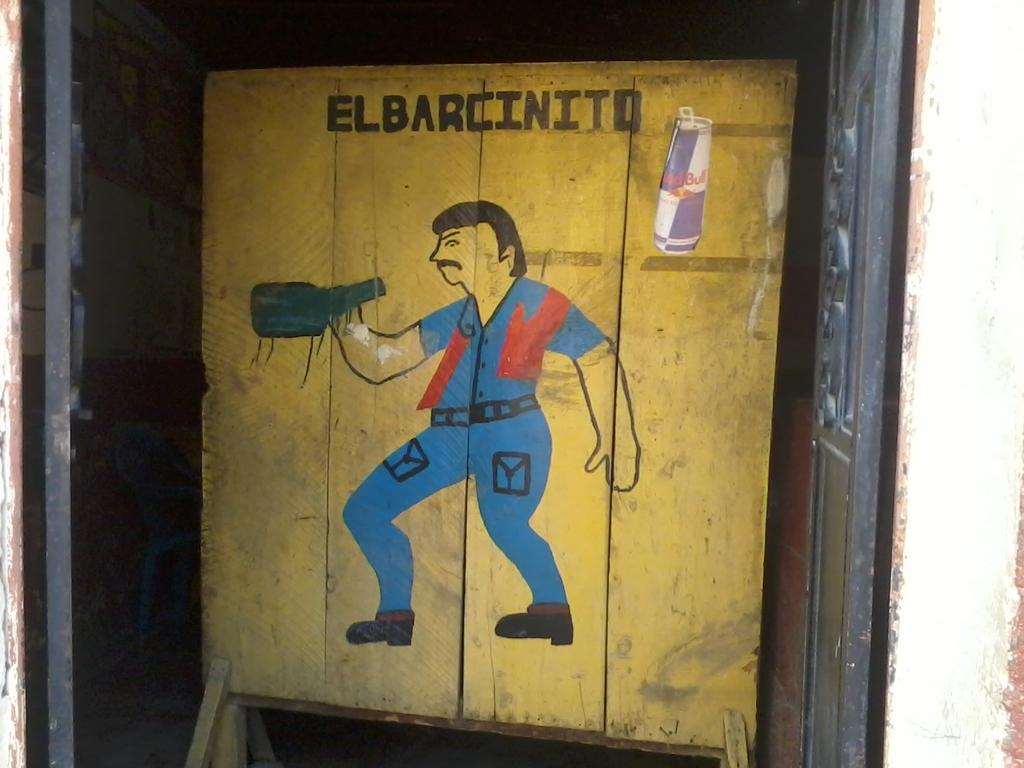<image>
Offer a succinct explanation of the picture presented. Red Bull is being advertised above a painting of a man in a blue outfit. 